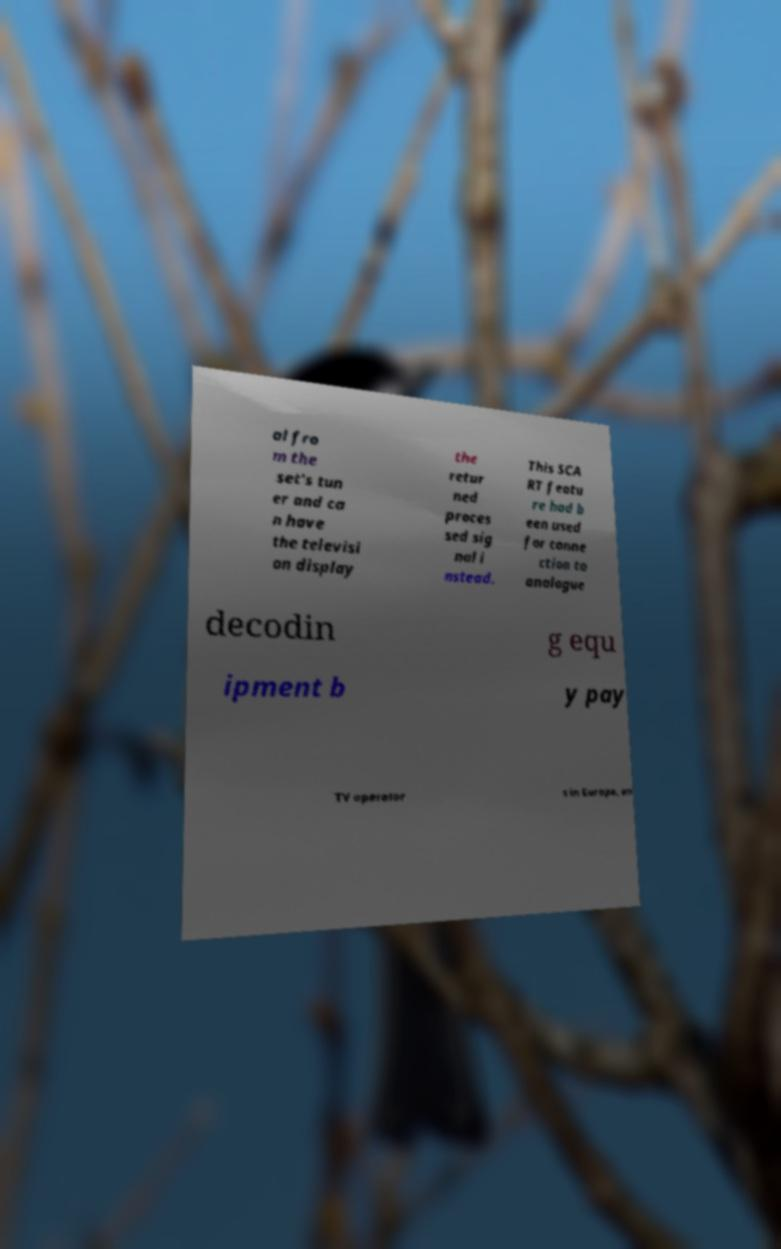For documentation purposes, I need the text within this image transcribed. Could you provide that? al fro m the set's tun er and ca n have the televisi on display the retur ned proces sed sig nal i nstead. This SCA RT featu re had b een used for conne ction to analogue decodin g equ ipment b y pay TV operator s in Europe, an 